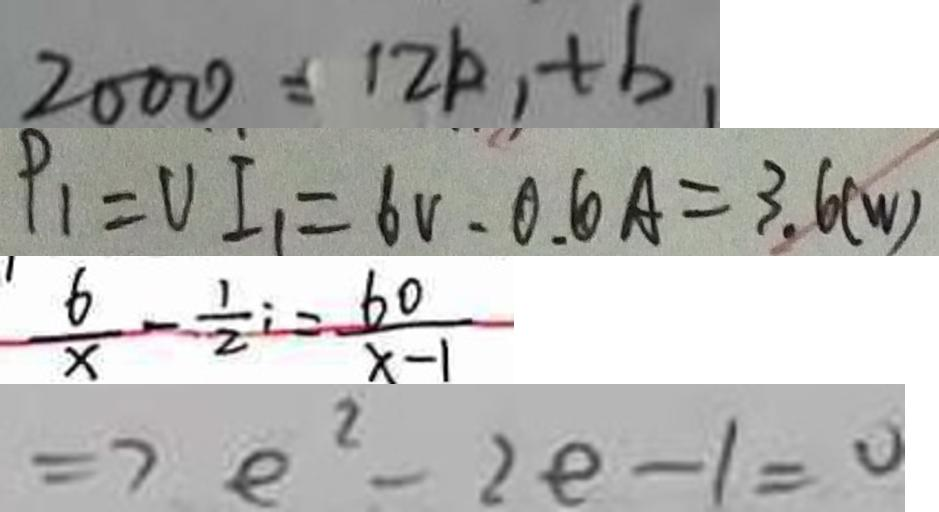Convert formula to latex. <formula><loc_0><loc_0><loc_500><loc_500>2 0 0 0 = 1 2 k , + b _ { 1 } 
 P _ { 1 } = V I _ { 1 } = 6 V \cdot 0 . 6 A = 3 . 6 ( w ) 
 \frac { 6 } { x } - \frac { 1 } { 2 } i = \frac { 6 0 } { x - 1 } 
 \Rightarrow e ^ { 2 } - 2 e - 1 = 0</formula> 